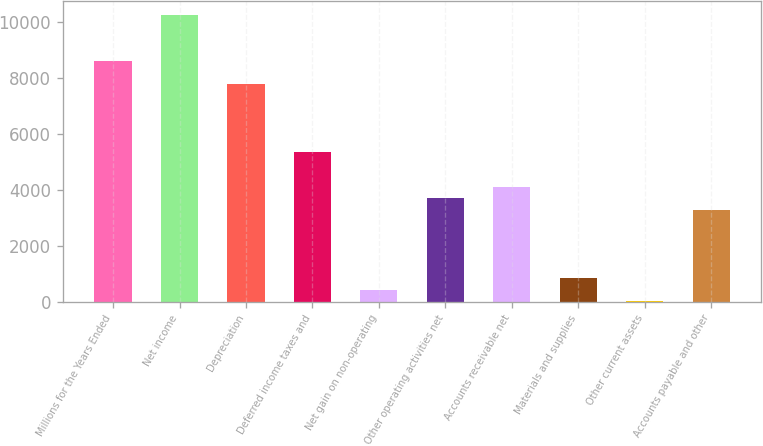<chart> <loc_0><loc_0><loc_500><loc_500><bar_chart><fcel>Millions for the Years Ended<fcel>Net income<fcel>Depreciation<fcel>Deferred income taxes and<fcel>Net gain on non-operating<fcel>Other operating activities net<fcel>Accounts receivable net<fcel>Materials and supplies<fcel>Other current assets<fcel>Accounts payable and other<nl><fcel>8601.8<fcel>10237<fcel>7784.2<fcel>5331.4<fcel>425.8<fcel>3696.2<fcel>4105<fcel>834.6<fcel>17<fcel>3287.4<nl></chart> 